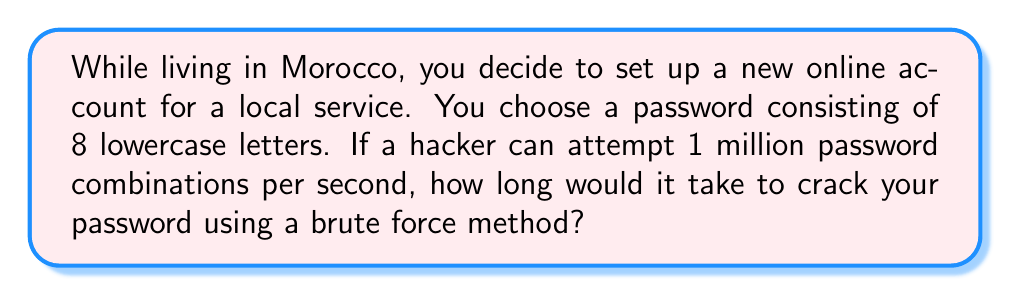Can you answer this question? Let's approach this step-by-step:

1. First, we need to calculate the total number of possible password combinations:
   - There are 26 lowercase letters in the English alphabet.
   - The password is 8 characters long.
   - So, the total number of combinations is $26^8$.

2. Calculate the total number of combinations:
   $$ \text{Total combinations} = 26^8 = 208,827,064,576 $$

3. Now, we know that the hacker can attempt 1 million (1,000,000) combinations per second.

4. To find the time required, we divide the total number of combinations by the attempts per second:
   $$ \text{Time (seconds)} = \frac{208,827,064,576}{1,000,000} = 208,827.064576 $$

5. Convert this to hours:
   $$ \text{Time (hours)} = \frac{208,827.064576}{3600} \approx 58.0075 $$

Therefore, it would take approximately 58 hours to crack the password using a brute force method.
Answer: 58 hours 